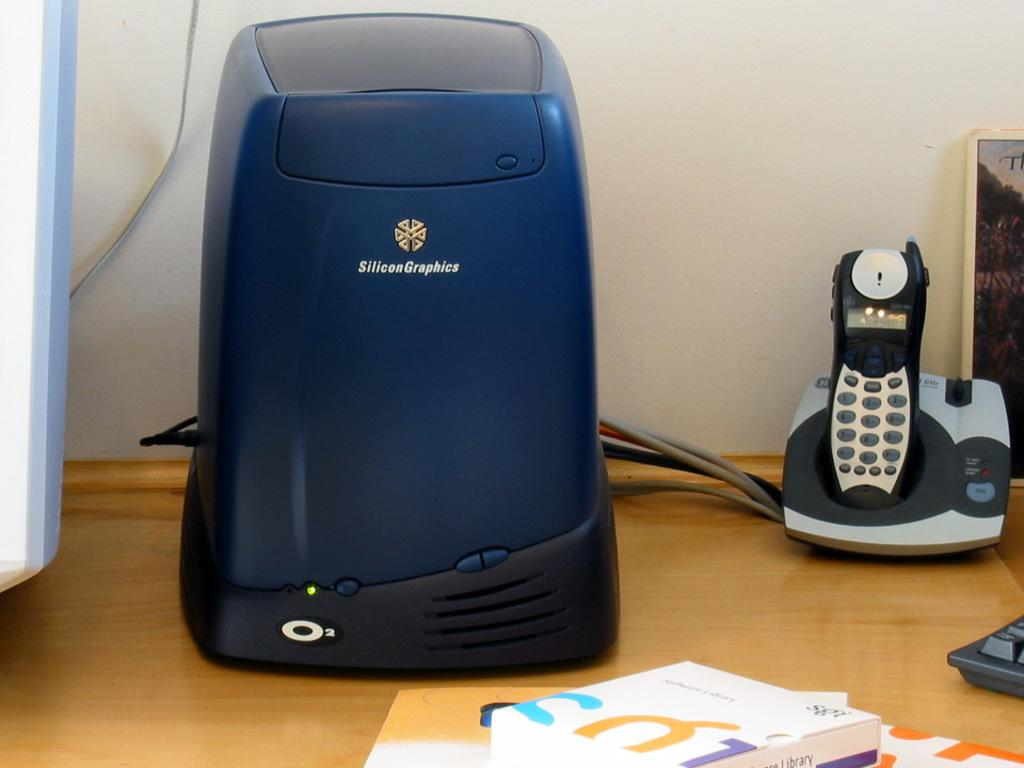<image>
Provide a brief description of the given image. A blue unit with the words Silicon Graphics written on it 